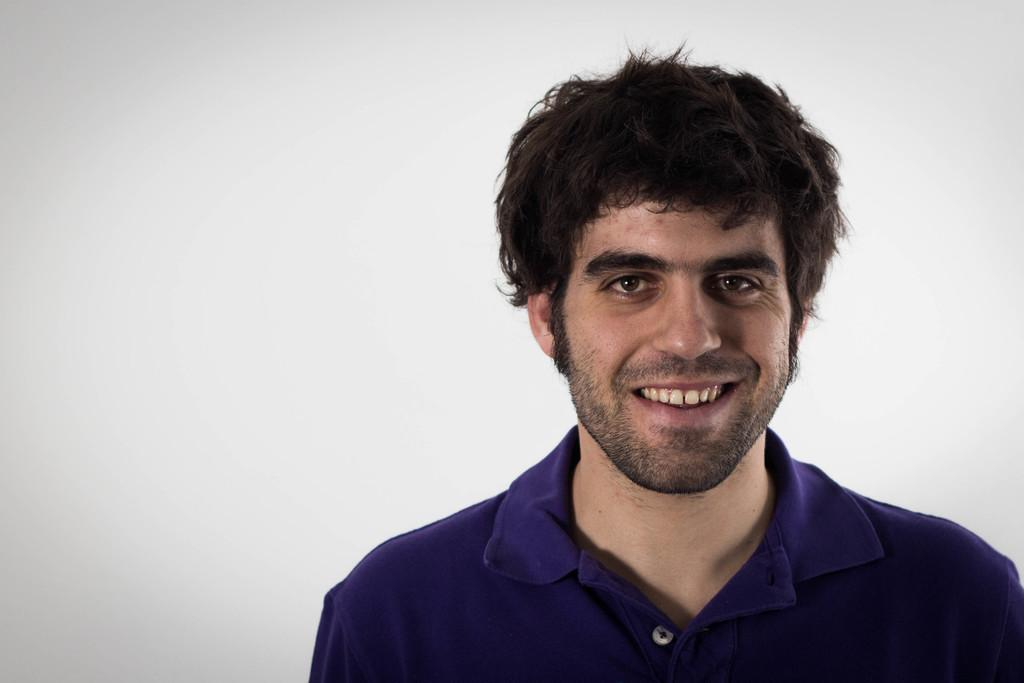Who is in the image? There is a man in the image. What is the man wearing? The man is wearing a violet t-shirt. What expression does the man have? The man is smiling. What is the man doing in the image? The man is posing for the photo. What color is the background of the image? The background of the image is white. What type of music can be heard playing in the background of the image? There is no music present in the image, as it is a still photograph. 